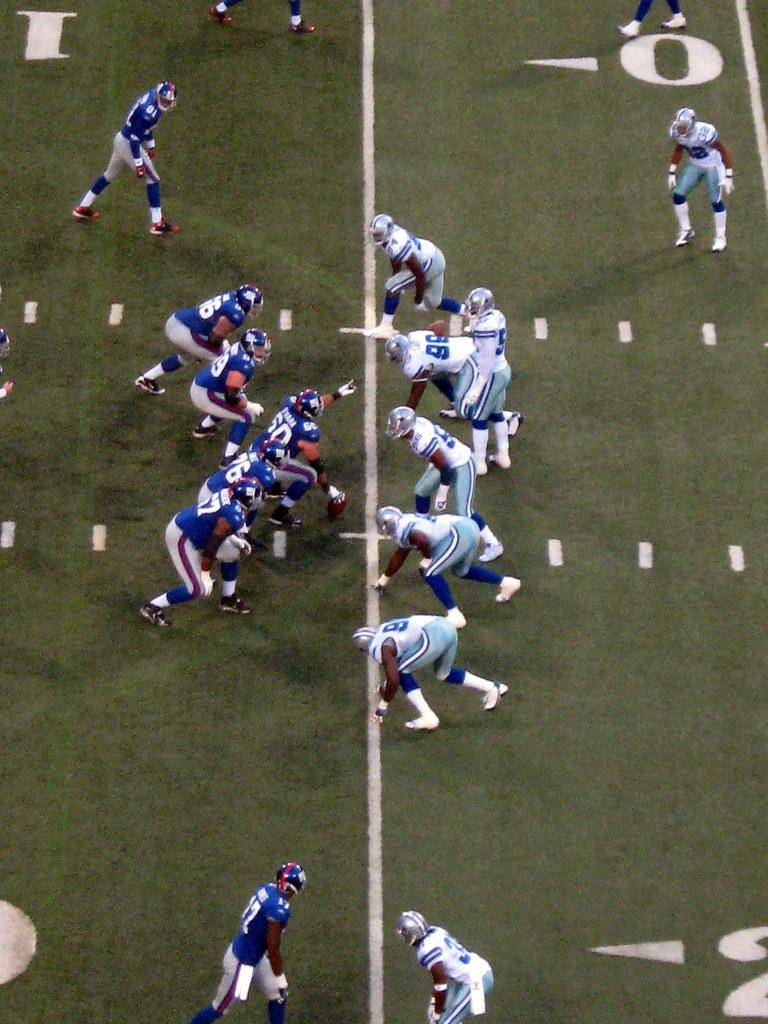What is happening in the image involving a group of people? The group of people are playing a game in the image. Where is the game being played? The game is being played on the ground. Can you identify any specific object being used in the game? Yes, there is a person holding a ball in the image. What type of shoe is being used to stop the ball during the game? There is no mention of a shoe being used to stop the ball in the image. The game is being played on the ground, but the specifics of how the ball is being played with are not described in the provided facts. 